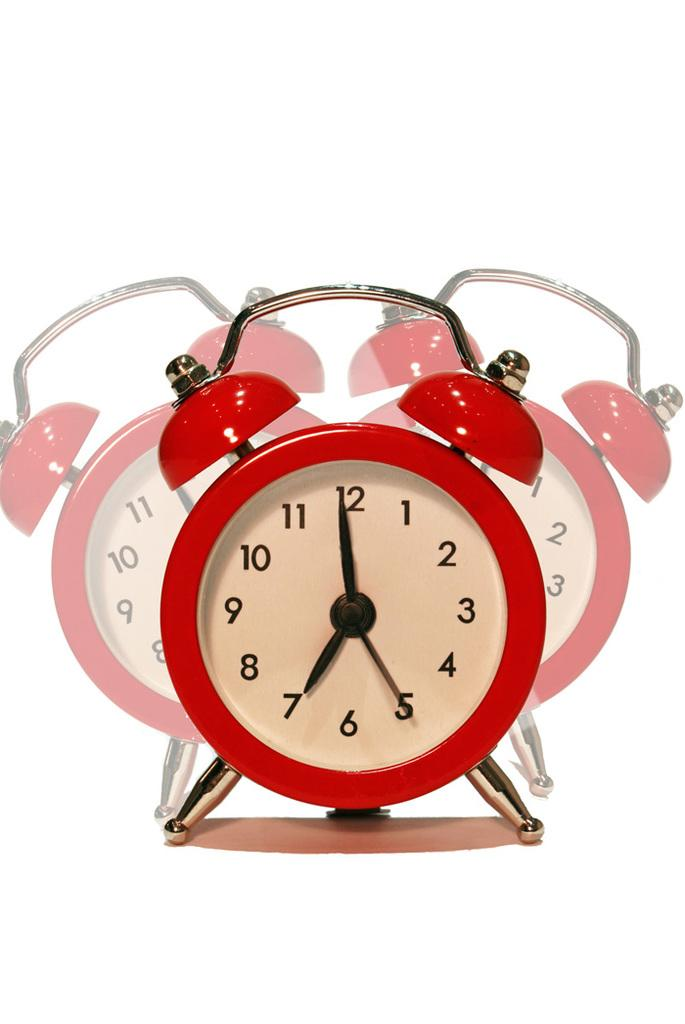<image>
Render a clear and concise summary of the photo. A red alarm clock that is showing the time of 7:00. 